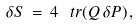<formula> <loc_0><loc_0><loc_500><loc_500>\delta S \, = \, 4 \, \ t r ( Q \, \delta P ) \, ,</formula> 